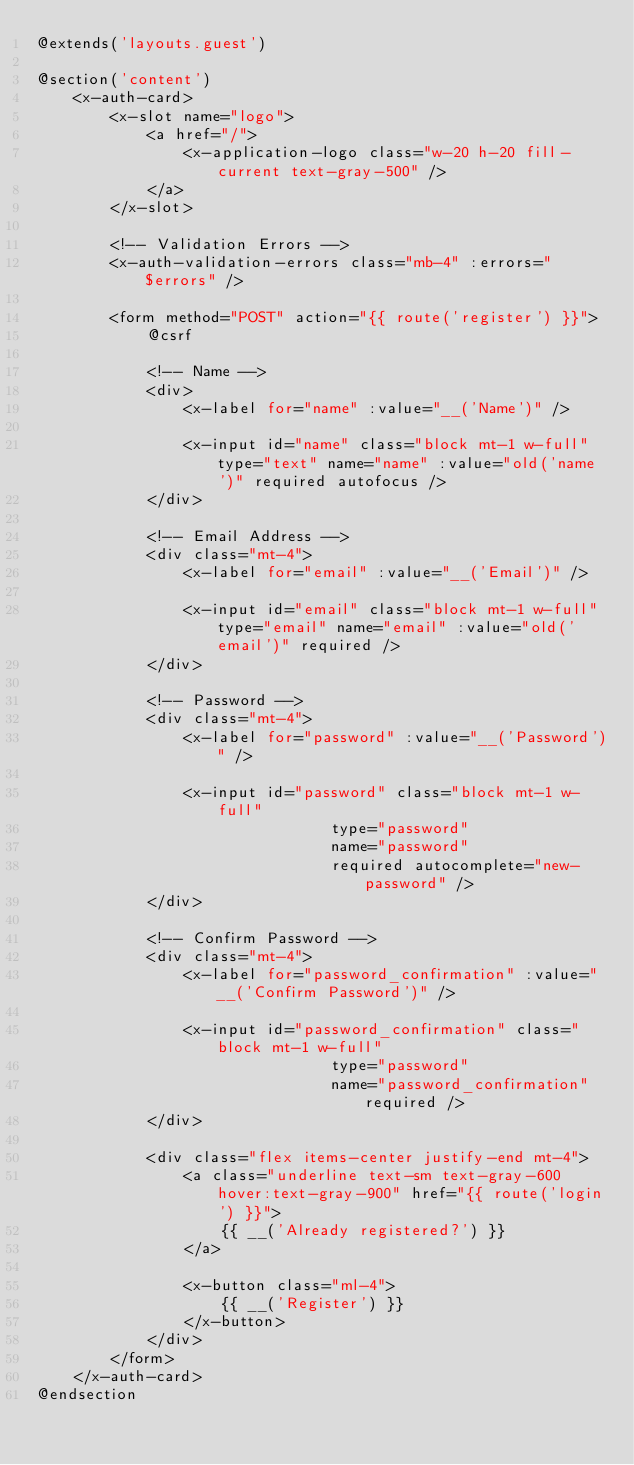<code> <loc_0><loc_0><loc_500><loc_500><_PHP_>@extends('layouts.guest')

@section('content')
    <x-auth-card>
        <x-slot name="logo">
            <a href="/">
                <x-application-logo class="w-20 h-20 fill-current text-gray-500" />
            </a>
        </x-slot>

        <!-- Validation Errors -->
        <x-auth-validation-errors class="mb-4" :errors="$errors" />

        <form method="POST" action="{{ route('register') }}">
            @csrf

            <!-- Name -->
            <div>
                <x-label for="name" :value="__('Name')" />

                <x-input id="name" class="block mt-1 w-full" type="text" name="name" :value="old('name')" required autofocus />
            </div>

            <!-- Email Address -->
            <div class="mt-4">
                <x-label for="email" :value="__('Email')" />

                <x-input id="email" class="block mt-1 w-full" type="email" name="email" :value="old('email')" required />
            </div>

            <!-- Password -->
            <div class="mt-4">
                <x-label for="password" :value="__('Password')" />

                <x-input id="password" class="block mt-1 w-full"
                                type="password"
                                name="password"
                                required autocomplete="new-password" />
            </div>

            <!-- Confirm Password -->
            <div class="mt-4">
                <x-label for="password_confirmation" :value="__('Confirm Password')" />

                <x-input id="password_confirmation" class="block mt-1 w-full"
                                type="password"
                                name="password_confirmation" required />
            </div>

            <div class="flex items-center justify-end mt-4">
                <a class="underline text-sm text-gray-600 hover:text-gray-900" href="{{ route('login') }}">
                    {{ __('Already registered?') }}
                </a>

                <x-button class="ml-4">
                    {{ __('Register') }}
                </x-button>
            </div>
        </form>
    </x-auth-card>
@endsection
</code> 